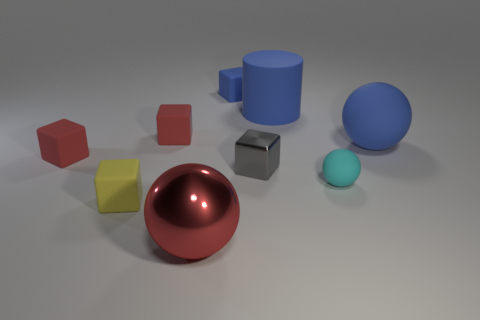The red metal sphere has what size?
Give a very brief answer. Large. How many big shiny spheres have the same color as the small metal cube?
Ensure brevity in your answer.  0. Are there any gray shiny objects that are to the right of the big sphere that is on the right side of the big rubber object that is left of the blue matte ball?
Keep it short and to the point. No. What shape is the red object that is the same size as the blue matte ball?
Your answer should be very brief. Sphere. How many small objects are blue things or cyan things?
Ensure brevity in your answer.  2. What color is the sphere that is made of the same material as the small gray cube?
Give a very brief answer. Red. There is a tiny thing behind the large blue rubber cylinder; is it the same shape as the metallic object to the right of the tiny blue rubber block?
Your answer should be compact. Yes. How many rubber things are either large spheres or blue blocks?
Ensure brevity in your answer.  2. There is a large cylinder that is the same color as the large matte ball; what material is it?
Keep it short and to the point. Rubber. Are there any other things that are the same shape as the small cyan rubber thing?
Your answer should be compact. Yes. 